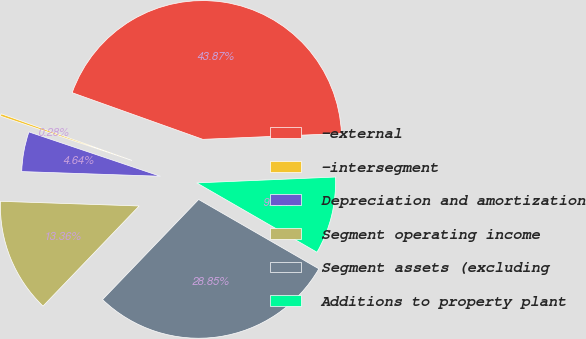Convert chart. <chart><loc_0><loc_0><loc_500><loc_500><pie_chart><fcel>-external<fcel>-intersegment<fcel>Depreciation and amortization<fcel>Segment operating income<fcel>Segment assets (excluding<fcel>Additions to property plant<nl><fcel>43.87%<fcel>0.28%<fcel>4.64%<fcel>13.36%<fcel>28.85%<fcel>9.0%<nl></chart> 